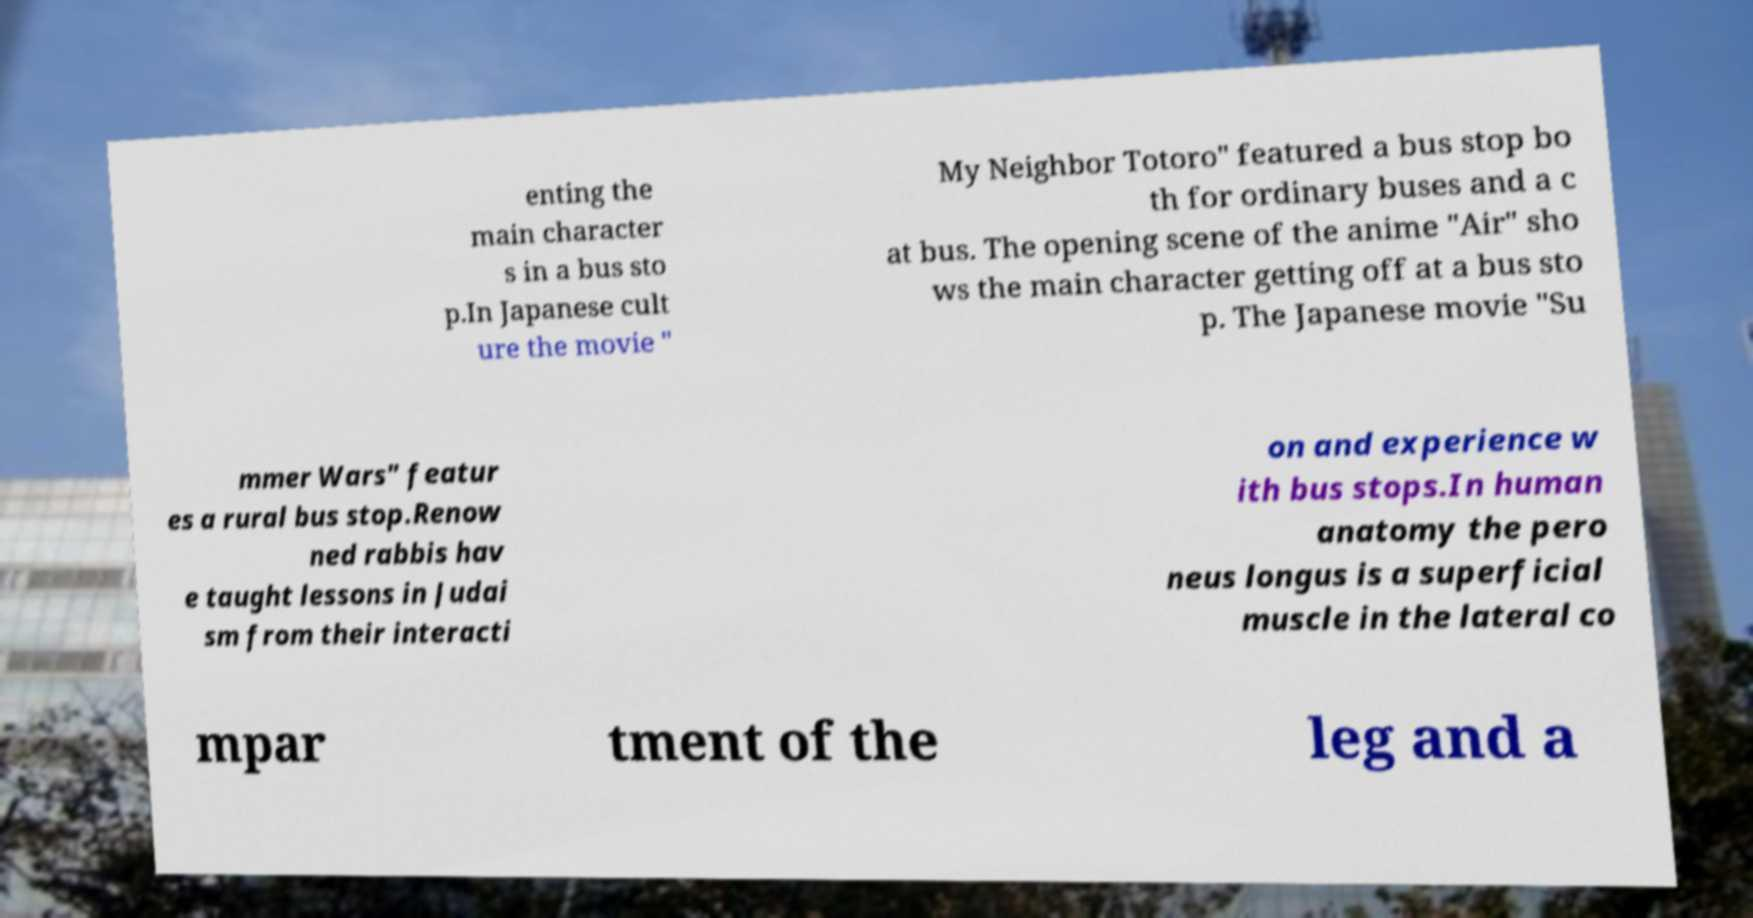What messages or text are displayed in this image? I need them in a readable, typed format. enting the main character s in a bus sto p.In Japanese cult ure the movie " My Neighbor Totoro" featured a bus stop bo th for ordinary buses and a c at bus. The opening scene of the anime "Air" sho ws the main character getting off at a bus sto p. The Japanese movie "Su mmer Wars" featur es a rural bus stop.Renow ned rabbis hav e taught lessons in Judai sm from their interacti on and experience w ith bus stops.In human anatomy the pero neus longus is a superficial muscle in the lateral co mpar tment of the leg and a 